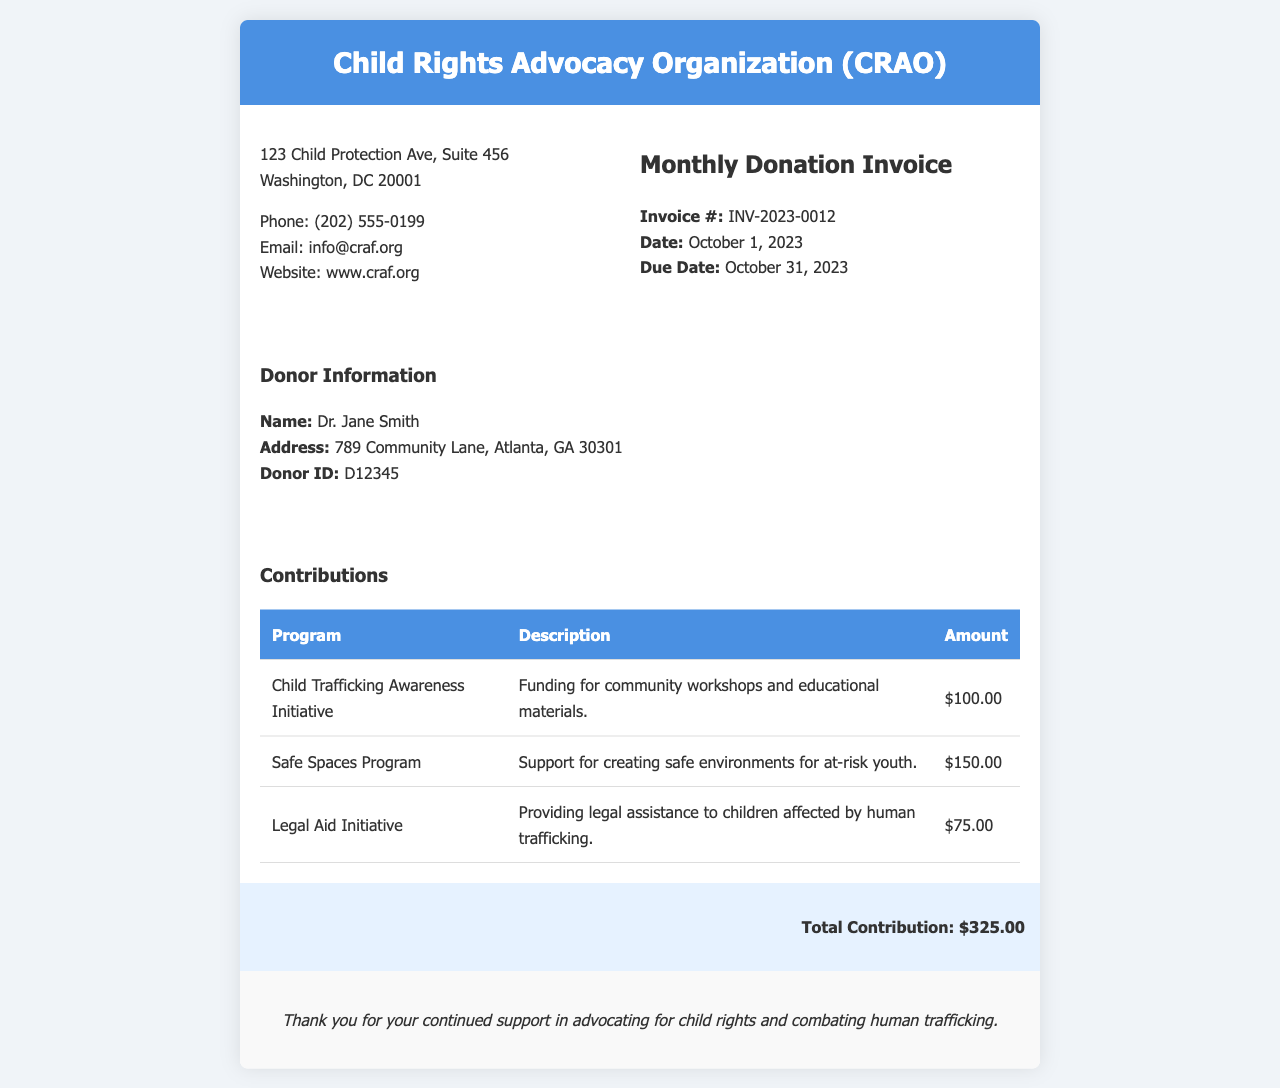what is the invoice number? The invoice number is specified in the document and is used for tracking payments.
Answer: INV-2023-0012 who is the donor? The donor's information is provided in the document, including their name.
Answer: Dr. Jane Smith what is the total contribution amount? The total contribution is calculated from the sums of all individual contributions listed in the invoice.
Answer: $325.00 when is the due date for the invoice? The due date is stated in the invoice section and indicates when the payment must be made.
Answer: October 31, 2023 what program supports creating safe environments for at-risk youth? This question requires recalling specific contributions made towards various programs listed in the document.
Answer: Safe Spaces Program how much funding is allocated for the Child Trafficking Awareness Initiative? The amount for each program is recorded in the contributions section of the invoice.
Answer: $100.00 what type of assistance does the Legal Aid Initiative provide? The description of the program in the document indicates the type of aid it offers.
Answer: Legal assistance to children affected by human trafficking what is the organization’s phone number? The organization’s contact information, including a phone number, is presented in the document.
Answer: (202) 555-0199 what is the address of the Child Rights Advocacy Organization? The document provides the organization’s physical location, which is important for contact purposes.
Answer: 123 Child Protection Ave, Suite 456, Washington, DC 20001 